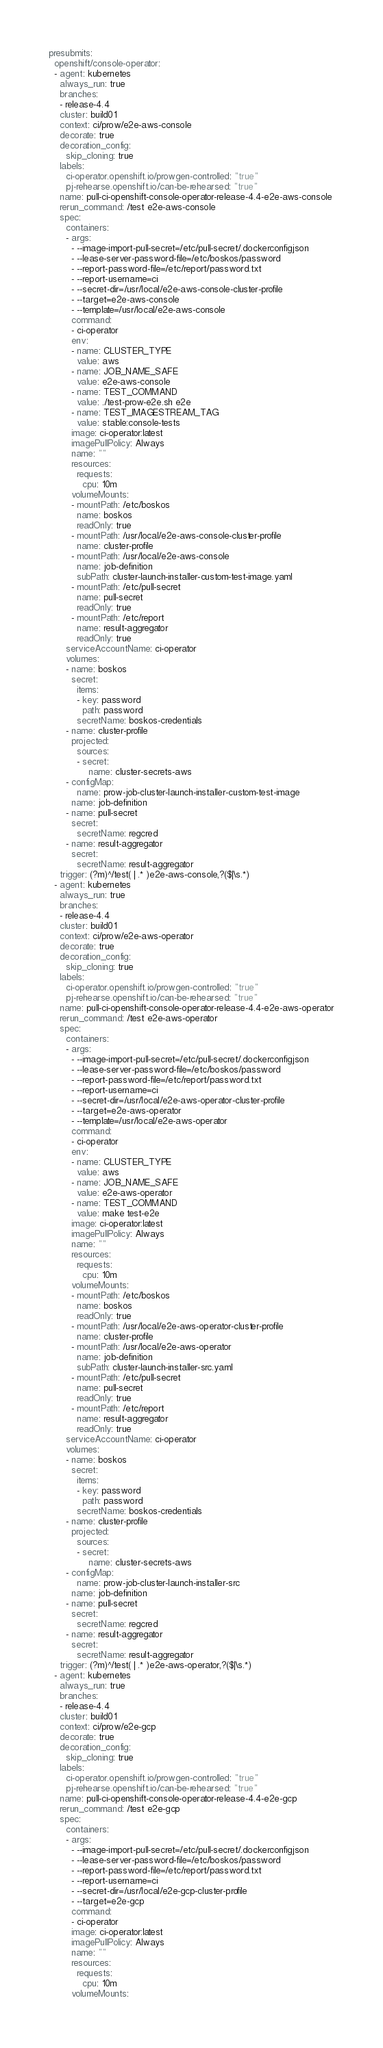Convert code to text. <code><loc_0><loc_0><loc_500><loc_500><_YAML_>presubmits:
  openshift/console-operator:
  - agent: kubernetes
    always_run: true
    branches:
    - release-4.4
    cluster: build01
    context: ci/prow/e2e-aws-console
    decorate: true
    decoration_config:
      skip_cloning: true
    labels:
      ci-operator.openshift.io/prowgen-controlled: "true"
      pj-rehearse.openshift.io/can-be-rehearsed: "true"
    name: pull-ci-openshift-console-operator-release-4.4-e2e-aws-console
    rerun_command: /test e2e-aws-console
    spec:
      containers:
      - args:
        - --image-import-pull-secret=/etc/pull-secret/.dockerconfigjson
        - --lease-server-password-file=/etc/boskos/password
        - --report-password-file=/etc/report/password.txt
        - --report-username=ci
        - --secret-dir=/usr/local/e2e-aws-console-cluster-profile
        - --target=e2e-aws-console
        - --template=/usr/local/e2e-aws-console
        command:
        - ci-operator
        env:
        - name: CLUSTER_TYPE
          value: aws
        - name: JOB_NAME_SAFE
          value: e2e-aws-console
        - name: TEST_COMMAND
          value: ./test-prow-e2e.sh e2e
        - name: TEST_IMAGESTREAM_TAG
          value: stable:console-tests
        image: ci-operator:latest
        imagePullPolicy: Always
        name: ""
        resources:
          requests:
            cpu: 10m
        volumeMounts:
        - mountPath: /etc/boskos
          name: boskos
          readOnly: true
        - mountPath: /usr/local/e2e-aws-console-cluster-profile
          name: cluster-profile
        - mountPath: /usr/local/e2e-aws-console
          name: job-definition
          subPath: cluster-launch-installer-custom-test-image.yaml
        - mountPath: /etc/pull-secret
          name: pull-secret
          readOnly: true
        - mountPath: /etc/report
          name: result-aggregator
          readOnly: true
      serviceAccountName: ci-operator
      volumes:
      - name: boskos
        secret:
          items:
          - key: password
            path: password
          secretName: boskos-credentials
      - name: cluster-profile
        projected:
          sources:
          - secret:
              name: cluster-secrets-aws
      - configMap:
          name: prow-job-cluster-launch-installer-custom-test-image
        name: job-definition
      - name: pull-secret
        secret:
          secretName: regcred
      - name: result-aggregator
        secret:
          secretName: result-aggregator
    trigger: (?m)^/test( | .* )e2e-aws-console,?($|\s.*)
  - agent: kubernetes
    always_run: true
    branches:
    - release-4.4
    cluster: build01
    context: ci/prow/e2e-aws-operator
    decorate: true
    decoration_config:
      skip_cloning: true
    labels:
      ci-operator.openshift.io/prowgen-controlled: "true"
      pj-rehearse.openshift.io/can-be-rehearsed: "true"
    name: pull-ci-openshift-console-operator-release-4.4-e2e-aws-operator
    rerun_command: /test e2e-aws-operator
    spec:
      containers:
      - args:
        - --image-import-pull-secret=/etc/pull-secret/.dockerconfigjson
        - --lease-server-password-file=/etc/boskos/password
        - --report-password-file=/etc/report/password.txt
        - --report-username=ci
        - --secret-dir=/usr/local/e2e-aws-operator-cluster-profile
        - --target=e2e-aws-operator
        - --template=/usr/local/e2e-aws-operator
        command:
        - ci-operator
        env:
        - name: CLUSTER_TYPE
          value: aws
        - name: JOB_NAME_SAFE
          value: e2e-aws-operator
        - name: TEST_COMMAND
          value: make test-e2e
        image: ci-operator:latest
        imagePullPolicy: Always
        name: ""
        resources:
          requests:
            cpu: 10m
        volumeMounts:
        - mountPath: /etc/boskos
          name: boskos
          readOnly: true
        - mountPath: /usr/local/e2e-aws-operator-cluster-profile
          name: cluster-profile
        - mountPath: /usr/local/e2e-aws-operator
          name: job-definition
          subPath: cluster-launch-installer-src.yaml
        - mountPath: /etc/pull-secret
          name: pull-secret
          readOnly: true
        - mountPath: /etc/report
          name: result-aggregator
          readOnly: true
      serviceAccountName: ci-operator
      volumes:
      - name: boskos
        secret:
          items:
          - key: password
            path: password
          secretName: boskos-credentials
      - name: cluster-profile
        projected:
          sources:
          - secret:
              name: cluster-secrets-aws
      - configMap:
          name: prow-job-cluster-launch-installer-src
        name: job-definition
      - name: pull-secret
        secret:
          secretName: regcred
      - name: result-aggregator
        secret:
          secretName: result-aggregator
    trigger: (?m)^/test( | .* )e2e-aws-operator,?($|\s.*)
  - agent: kubernetes
    always_run: true
    branches:
    - release-4.4
    cluster: build01
    context: ci/prow/e2e-gcp
    decorate: true
    decoration_config:
      skip_cloning: true
    labels:
      ci-operator.openshift.io/prowgen-controlled: "true"
      pj-rehearse.openshift.io/can-be-rehearsed: "true"
    name: pull-ci-openshift-console-operator-release-4.4-e2e-gcp
    rerun_command: /test e2e-gcp
    spec:
      containers:
      - args:
        - --image-import-pull-secret=/etc/pull-secret/.dockerconfigjson
        - --lease-server-password-file=/etc/boskos/password
        - --report-password-file=/etc/report/password.txt
        - --report-username=ci
        - --secret-dir=/usr/local/e2e-gcp-cluster-profile
        - --target=e2e-gcp
        command:
        - ci-operator
        image: ci-operator:latest
        imagePullPolicy: Always
        name: ""
        resources:
          requests:
            cpu: 10m
        volumeMounts:</code> 